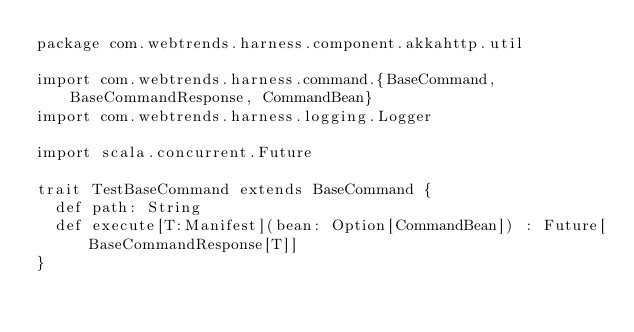<code> <loc_0><loc_0><loc_500><loc_500><_Scala_>package com.webtrends.harness.component.akkahttp.util

import com.webtrends.harness.command.{BaseCommand, BaseCommandResponse, CommandBean}
import com.webtrends.harness.logging.Logger

import scala.concurrent.Future

trait TestBaseCommand extends BaseCommand {
  def path: String
  def execute[T:Manifest](bean: Option[CommandBean]) : Future[BaseCommandResponse[T]]
}
</code> 